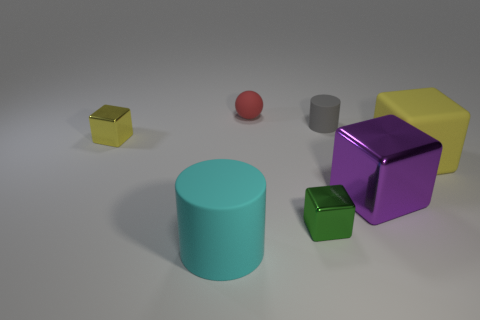Subtract all shiny cubes. How many cubes are left? 1 Subtract all cyan cylinders. How many cylinders are left? 1 Subtract all balls. How many objects are left? 6 Add 1 blue metallic spheres. How many objects exist? 8 Subtract 0 green balls. How many objects are left? 7 Subtract 1 spheres. How many spheres are left? 0 Subtract all green cylinders. Subtract all brown cubes. How many cylinders are left? 2 Subtract all gray spheres. How many gray cylinders are left? 1 Subtract all small rubber spheres. Subtract all tiny green shiny cubes. How many objects are left? 5 Add 1 yellow cubes. How many yellow cubes are left? 3 